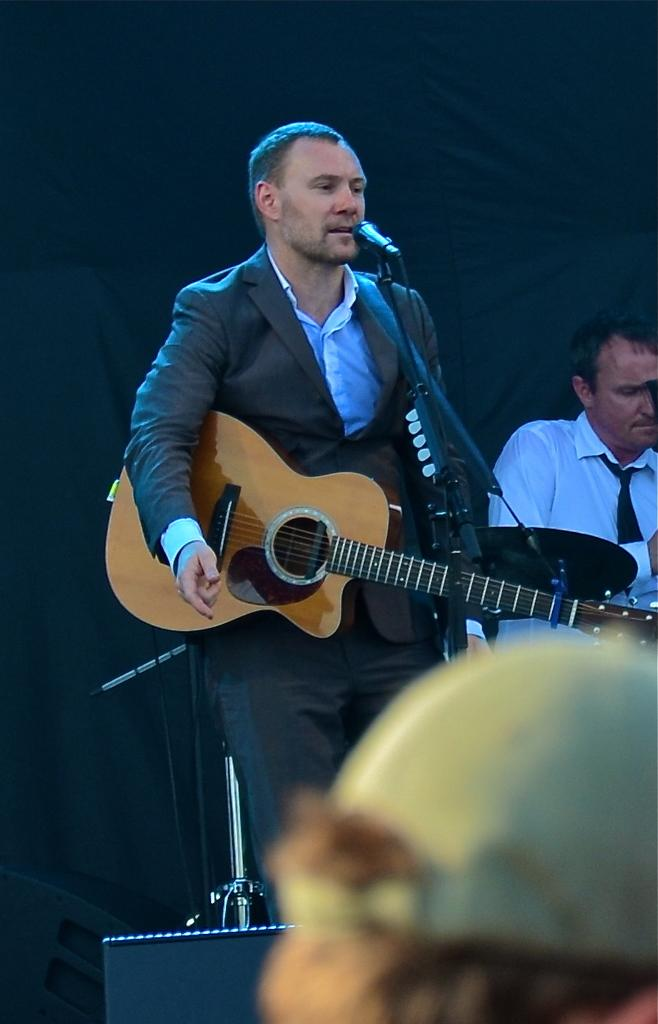What is the man wearing in the image? The man is wearing a black suit in the image. What is the man doing while wearing the suit? The man is playing a guitar and singing in the image. Where is the man positioned in relation to the microphone? The man is in front of a microphone in the image. What can be seen in the background of the image? There is a black curtain in the background of the image. How is the man sitting in the image? The man is sitting while playing the guitar and singing. How many ladybugs can be seen on the man's guitar in the image? There are no ladybugs present on the man's guitar in the image. What type of work does the man do as a carpenter in the image? The man is not depicted as a carpenter in the image; he is playing a guitar and singing. 